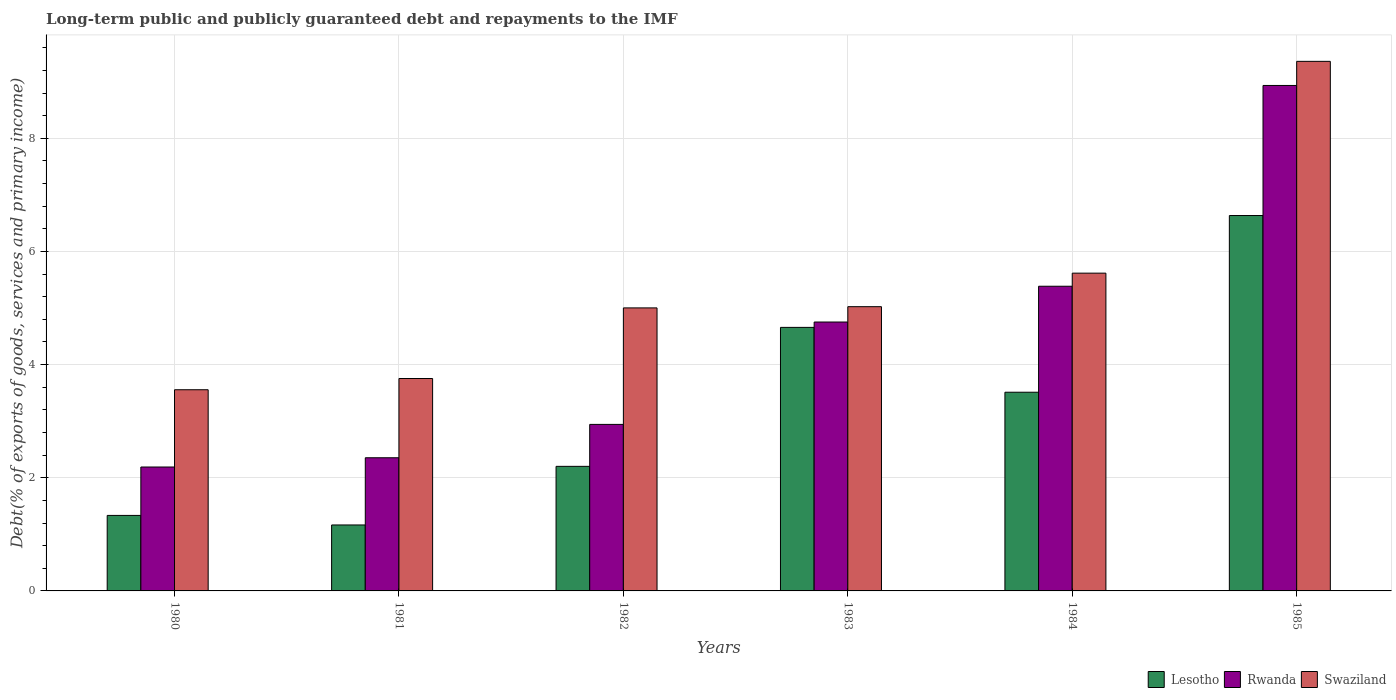Are the number of bars per tick equal to the number of legend labels?
Your answer should be compact. Yes. Are the number of bars on each tick of the X-axis equal?
Give a very brief answer. Yes. How many bars are there on the 3rd tick from the left?
Provide a short and direct response. 3. How many bars are there on the 5th tick from the right?
Your answer should be compact. 3. What is the label of the 6th group of bars from the left?
Provide a succinct answer. 1985. What is the debt and repayments in Swaziland in 1981?
Your answer should be compact. 3.75. Across all years, what is the maximum debt and repayments in Rwanda?
Your answer should be very brief. 8.93. Across all years, what is the minimum debt and repayments in Swaziland?
Your answer should be compact. 3.56. What is the total debt and repayments in Rwanda in the graph?
Provide a short and direct response. 26.56. What is the difference between the debt and repayments in Rwanda in 1980 and that in 1981?
Keep it short and to the point. -0.16. What is the difference between the debt and repayments in Rwanda in 1981 and the debt and repayments in Lesotho in 1980?
Offer a very short reply. 1.02. What is the average debt and repayments in Rwanda per year?
Your answer should be compact. 4.43. In the year 1981, what is the difference between the debt and repayments in Rwanda and debt and repayments in Lesotho?
Your answer should be very brief. 1.19. What is the ratio of the debt and repayments in Lesotho in 1983 to that in 1984?
Give a very brief answer. 1.33. Is the difference between the debt and repayments in Rwanda in 1980 and 1984 greater than the difference between the debt and repayments in Lesotho in 1980 and 1984?
Keep it short and to the point. No. What is the difference between the highest and the second highest debt and repayments in Rwanda?
Offer a very short reply. 3.55. What is the difference between the highest and the lowest debt and repayments in Lesotho?
Provide a short and direct response. 5.47. In how many years, is the debt and repayments in Rwanda greater than the average debt and repayments in Rwanda taken over all years?
Keep it short and to the point. 3. Is the sum of the debt and repayments in Rwanda in 1981 and 1983 greater than the maximum debt and repayments in Lesotho across all years?
Keep it short and to the point. Yes. What does the 1st bar from the left in 1980 represents?
Make the answer very short. Lesotho. What does the 3rd bar from the right in 1985 represents?
Offer a terse response. Lesotho. How many bars are there?
Your response must be concise. 18. How many years are there in the graph?
Give a very brief answer. 6. What is the difference between two consecutive major ticks on the Y-axis?
Ensure brevity in your answer.  2. Are the values on the major ticks of Y-axis written in scientific E-notation?
Make the answer very short. No. Does the graph contain grids?
Offer a terse response. Yes. Where does the legend appear in the graph?
Provide a short and direct response. Bottom right. How many legend labels are there?
Give a very brief answer. 3. What is the title of the graph?
Make the answer very short. Long-term public and publicly guaranteed debt and repayments to the IMF. What is the label or title of the X-axis?
Give a very brief answer. Years. What is the label or title of the Y-axis?
Your response must be concise. Debt(% of exports of goods, services and primary income). What is the Debt(% of exports of goods, services and primary income) in Lesotho in 1980?
Make the answer very short. 1.33. What is the Debt(% of exports of goods, services and primary income) of Rwanda in 1980?
Provide a short and direct response. 2.19. What is the Debt(% of exports of goods, services and primary income) in Swaziland in 1980?
Offer a terse response. 3.56. What is the Debt(% of exports of goods, services and primary income) in Lesotho in 1981?
Your answer should be compact. 1.17. What is the Debt(% of exports of goods, services and primary income) of Rwanda in 1981?
Make the answer very short. 2.35. What is the Debt(% of exports of goods, services and primary income) of Swaziland in 1981?
Provide a short and direct response. 3.75. What is the Debt(% of exports of goods, services and primary income) in Lesotho in 1982?
Your response must be concise. 2.2. What is the Debt(% of exports of goods, services and primary income) of Rwanda in 1982?
Provide a succinct answer. 2.94. What is the Debt(% of exports of goods, services and primary income) of Swaziland in 1982?
Provide a short and direct response. 5. What is the Debt(% of exports of goods, services and primary income) in Lesotho in 1983?
Your response must be concise. 4.66. What is the Debt(% of exports of goods, services and primary income) of Rwanda in 1983?
Offer a terse response. 4.75. What is the Debt(% of exports of goods, services and primary income) of Swaziland in 1983?
Provide a succinct answer. 5.02. What is the Debt(% of exports of goods, services and primary income) of Lesotho in 1984?
Provide a succinct answer. 3.51. What is the Debt(% of exports of goods, services and primary income) in Rwanda in 1984?
Provide a succinct answer. 5.38. What is the Debt(% of exports of goods, services and primary income) in Swaziland in 1984?
Your answer should be very brief. 5.62. What is the Debt(% of exports of goods, services and primary income) of Lesotho in 1985?
Your response must be concise. 6.63. What is the Debt(% of exports of goods, services and primary income) in Rwanda in 1985?
Ensure brevity in your answer.  8.93. What is the Debt(% of exports of goods, services and primary income) of Swaziland in 1985?
Offer a very short reply. 9.36. Across all years, what is the maximum Debt(% of exports of goods, services and primary income) in Lesotho?
Your answer should be compact. 6.63. Across all years, what is the maximum Debt(% of exports of goods, services and primary income) in Rwanda?
Provide a short and direct response. 8.93. Across all years, what is the maximum Debt(% of exports of goods, services and primary income) of Swaziland?
Give a very brief answer. 9.36. Across all years, what is the minimum Debt(% of exports of goods, services and primary income) of Lesotho?
Your answer should be very brief. 1.17. Across all years, what is the minimum Debt(% of exports of goods, services and primary income) of Rwanda?
Your answer should be very brief. 2.19. Across all years, what is the minimum Debt(% of exports of goods, services and primary income) of Swaziland?
Your answer should be very brief. 3.56. What is the total Debt(% of exports of goods, services and primary income) of Lesotho in the graph?
Your response must be concise. 19.51. What is the total Debt(% of exports of goods, services and primary income) in Rwanda in the graph?
Keep it short and to the point. 26.56. What is the total Debt(% of exports of goods, services and primary income) of Swaziland in the graph?
Keep it short and to the point. 32.31. What is the difference between the Debt(% of exports of goods, services and primary income) in Lesotho in 1980 and that in 1981?
Provide a succinct answer. 0.17. What is the difference between the Debt(% of exports of goods, services and primary income) in Rwanda in 1980 and that in 1981?
Provide a succinct answer. -0.16. What is the difference between the Debt(% of exports of goods, services and primary income) in Swaziland in 1980 and that in 1981?
Offer a very short reply. -0.2. What is the difference between the Debt(% of exports of goods, services and primary income) in Lesotho in 1980 and that in 1982?
Make the answer very short. -0.87. What is the difference between the Debt(% of exports of goods, services and primary income) of Rwanda in 1980 and that in 1982?
Provide a short and direct response. -0.75. What is the difference between the Debt(% of exports of goods, services and primary income) of Swaziland in 1980 and that in 1982?
Make the answer very short. -1.45. What is the difference between the Debt(% of exports of goods, services and primary income) in Lesotho in 1980 and that in 1983?
Provide a short and direct response. -3.32. What is the difference between the Debt(% of exports of goods, services and primary income) in Rwanda in 1980 and that in 1983?
Keep it short and to the point. -2.56. What is the difference between the Debt(% of exports of goods, services and primary income) in Swaziland in 1980 and that in 1983?
Make the answer very short. -1.47. What is the difference between the Debt(% of exports of goods, services and primary income) in Lesotho in 1980 and that in 1984?
Your response must be concise. -2.18. What is the difference between the Debt(% of exports of goods, services and primary income) of Rwanda in 1980 and that in 1984?
Offer a very short reply. -3.19. What is the difference between the Debt(% of exports of goods, services and primary income) in Swaziland in 1980 and that in 1984?
Keep it short and to the point. -2.06. What is the difference between the Debt(% of exports of goods, services and primary income) of Lesotho in 1980 and that in 1985?
Offer a very short reply. -5.3. What is the difference between the Debt(% of exports of goods, services and primary income) of Rwanda in 1980 and that in 1985?
Your answer should be very brief. -6.74. What is the difference between the Debt(% of exports of goods, services and primary income) of Swaziland in 1980 and that in 1985?
Provide a succinct answer. -5.8. What is the difference between the Debt(% of exports of goods, services and primary income) of Lesotho in 1981 and that in 1982?
Give a very brief answer. -1.04. What is the difference between the Debt(% of exports of goods, services and primary income) in Rwanda in 1981 and that in 1982?
Give a very brief answer. -0.59. What is the difference between the Debt(% of exports of goods, services and primary income) of Swaziland in 1981 and that in 1982?
Offer a terse response. -1.25. What is the difference between the Debt(% of exports of goods, services and primary income) in Lesotho in 1981 and that in 1983?
Your response must be concise. -3.49. What is the difference between the Debt(% of exports of goods, services and primary income) in Rwanda in 1981 and that in 1983?
Offer a very short reply. -2.4. What is the difference between the Debt(% of exports of goods, services and primary income) of Swaziland in 1981 and that in 1983?
Your answer should be very brief. -1.27. What is the difference between the Debt(% of exports of goods, services and primary income) in Lesotho in 1981 and that in 1984?
Offer a very short reply. -2.35. What is the difference between the Debt(% of exports of goods, services and primary income) in Rwanda in 1981 and that in 1984?
Provide a short and direct response. -3.03. What is the difference between the Debt(% of exports of goods, services and primary income) in Swaziland in 1981 and that in 1984?
Your answer should be very brief. -1.86. What is the difference between the Debt(% of exports of goods, services and primary income) in Lesotho in 1981 and that in 1985?
Make the answer very short. -5.47. What is the difference between the Debt(% of exports of goods, services and primary income) of Rwanda in 1981 and that in 1985?
Give a very brief answer. -6.58. What is the difference between the Debt(% of exports of goods, services and primary income) of Swaziland in 1981 and that in 1985?
Keep it short and to the point. -5.61. What is the difference between the Debt(% of exports of goods, services and primary income) in Lesotho in 1982 and that in 1983?
Your answer should be compact. -2.46. What is the difference between the Debt(% of exports of goods, services and primary income) of Rwanda in 1982 and that in 1983?
Provide a succinct answer. -1.81. What is the difference between the Debt(% of exports of goods, services and primary income) of Swaziland in 1982 and that in 1983?
Provide a short and direct response. -0.02. What is the difference between the Debt(% of exports of goods, services and primary income) of Lesotho in 1982 and that in 1984?
Your answer should be very brief. -1.31. What is the difference between the Debt(% of exports of goods, services and primary income) in Rwanda in 1982 and that in 1984?
Provide a short and direct response. -2.44. What is the difference between the Debt(% of exports of goods, services and primary income) in Swaziland in 1982 and that in 1984?
Your answer should be very brief. -0.61. What is the difference between the Debt(% of exports of goods, services and primary income) in Lesotho in 1982 and that in 1985?
Ensure brevity in your answer.  -4.43. What is the difference between the Debt(% of exports of goods, services and primary income) in Rwanda in 1982 and that in 1985?
Give a very brief answer. -5.99. What is the difference between the Debt(% of exports of goods, services and primary income) in Swaziland in 1982 and that in 1985?
Offer a very short reply. -4.36. What is the difference between the Debt(% of exports of goods, services and primary income) in Lesotho in 1983 and that in 1984?
Keep it short and to the point. 1.15. What is the difference between the Debt(% of exports of goods, services and primary income) in Rwanda in 1983 and that in 1984?
Make the answer very short. -0.63. What is the difference between the Debt(% of exports of goods, services and primary income) of Swaziland in 1983 and that in 1984?
Your response must be concise. -0.59. What is the difference between the Debt(% of exports of goods, services and primary income) in Lesotho in 1983 and that in 1985?
Provide a short and direct response. -1.98. What is the difference between the Debt(% of exports of goods, services and primary income) of Rwanda in 1983 and that in 1985?
Offer a very short reply. -4.18. What is the difference between the Debt(% of exports of goods, services and primary income) of Swaziland in 1983 and that in 1985?
Offer a very short reply. -4.34. What is the difference between the Debt(% of exports of goods, services and primary income) of Lesotho in 1984 and that in 1985?
Give a very brief answer. -3.12. What is the difference between the Debt(% of exports of goods, services and primary income) in Rwanda in 1984 and that in 1985?
Keep it short and to the point. -3.55. What is the difference between the Debt(% of exports of goods, services and primary income) in Swaziland in 1984 and that in 1985?
Offer a terse response. -3.74. What is the difference between the Debt(% of exports of goods, services and primary income) in Lesotho in 1980 and the Debt(% of exports of goods, services and primary income) in Rwanda in 1981?
Provide a succinct answer. -1.02. What is the difference between the Debt(% of exports of goods, services and primary income) of Lesotho in 1980 and the Debt(% of exports of goods, services and primary income) of Swaziland in 1981?
Provide a short and direct response. -2.42. What is the difference between the Debt(% of exports of goods, services and primary income) of Rwanda in 1980 and the Debt(% of exports of goods, services and primary income) of Swaziland in 1981?
Ensure brevity in your answer.  -1.56. What is the difference between the Debt(% of exports of goods, services and primary income) of Lesotho in 1980 and the Debt(% of exports of goods, services and primary income) of Rwanda in 1982?
Give a very brief answer. -1.61. What is the difference between the Debt(% of exports of goods, services and primary income) of Lesotho in 1980 and the Debt(% of exports of goods, services and primary income) of Swaziland in 1982?
Offer a very short reply. -3.67. What is the difference between the Debt(% of exports of goods, services and primary income) of Rwanda in 1980 and the Debt(% of exports of goods, services and primary income) of Swaziland in 1982?
Offer a very short reply. -2.81. What is the difference between the Debt(% of exports of goods, services and primary income) in Lesotho in 1980 and the Debt(% of exports of goods, services and primary income) in Rwanda in 1983?
Make the answer very short. -3.42. What is the difference between the Debt(% of exports of goods, services and primary income) in Lesotho in 1980 and the Debt(% of exports of goods, services and primary income) in Swaziland in 1983?
Your response must be concise. -3.69. What is the difference between the Debt(% of exports of goods, services and primary income) of Rwanda in 1980 and the Debt(% of exports of goods, services and primary income) of Swaziland in 1983?
Keep it short and to the point. -2.83. What is the difference between the Debt(% of exports of goods, services and primary income) of Lesotho in 1980 and the Debt(% of exports of goods, services and primary income) of Rwanda in 1984?
Provide a short and direct response. -4.05. What is the difference between the Debt(% of exports of goods, services and primary income) of Lesotho in 1980 and the Debt(% of exports of goods, services and primary income) of Swaziland in 1984?
Your answer should be compact. -4.28. What is the difference between the Debt(% of exports of goods, services and primary income) in Rwanda in 1980 and the Debt(% of exports of goods, services and primary income) in Swaziland in 1984?
Offer a very short reply. -3.43. What is the difference between the Debt(% of exports of goods, services and primary income) of Lesotho in 1980 and the Debt(% of exports of goods, services and primary income) of Rwanda in 1985?
Provide a succinct answer. -7.6. What is the difference between the Debt(% of exports of goods, services and primary income) of Lesotho in 1980 and the Debt(% of exports of goods, services and primary income) of Swaziland in 1985?
Ensure brevity in your answer.  -8.02. What is the difference between the Debt(% of exports of goods, services and primary income) of Rwanda in 1980 and the Debt(% of exports of goods, services and primary income) of Swaziland in 1985?
Keep it short and to the point. -7.17. What is the difference between the Debt(% of exports of goods, services and primary income) in Lesotho in 1981 and the Debt(% of exports of goods, services and primary income) in Rwanda in 1982?
Your response must be concise. -1.78. What is the difference between the Debt(% of exports of goods, services and primary income) of Lesotho in 1981 and the Debt(% of exports of goods, services and primary income) of Swaziland in 1982?
Provide a succinct answer. -3.84. What is the difference between the Debt(% of exports of goods, services and primary income) of Rwanda in 1981 and the Debt(% of exports of goods, services and primary income) of Swaziland in 1982?
Your answer should be compact. -2.65. What is the difference between the Debt(% of exports of goods, services and primary income) in Lesotho in 1981 and the Debt(% of exports of goods, services and primary income) in Rwanda in 1983?
Offer a very short reply. -3.59. What is the difference between the Debt(% of exports of goods, services and primary income) of Lesotho in 1981 and the Debt(% of exports of goods, services and primary income) of Swaziland in 1983?
Keep it short and to the point. -3.86. What is the difference between the Debt(% of exports of goods, services and primary income) of Rwanda in 1981 and the Debt(% of exports of goods, services and primary income) of Swaziland in 1983?
Keep it short and to the point. -2.67. What is the difference between the Debt(% of exports of goods, services and primary income) of Lesotho in 1981 and the Debt(% of exports of goods, services and primary income) of Rwanda in 1984?
Your answer should be very brief. -4.22. What is the difference between the Debt(% of exports of goods, services and primary income) of Lesotho in 1981 and the Debt(% of exports of goods, services and primary income) of Swaziland in 1984?
Your response must be concise. -4.45. What is the difference between the Debt(% of exports of goods, services and primary income) of Rwanda in 1981 and the Debt(% of exports of goods, services and primary income) of Swaziland in 1984?
Offer a very short reply. -3.26. What is the difference between the Debt(% of exports of goods, services and primary income) in Lesotho in 1981 and the Debt(% of exports of goods, services and primary income) in Rwanda in 1985?
Provide a succinct answer. -7.77. What is the difference between the Debt(% of exports of goods, services and primary income) of Lesotho in 1981 and the Debt(% of exports of goods, services and primary income) of Swaziland in 1985?
Provide a succinct answer. -8.19. What is the difference between the Debt(% of exports of goods, services and primary income) of Rwanda in 1981 and the Debt(% of exports of goods, services and primary income) of Swaziland in 1985?
Your answer should be very brief. -7.01. What is the difference between the Debt(% of exports of goods, services and primary income) in Lesotho in 1982 and the Debt(% of exports of goods, services and primary income) in Rwanda in 1983?
Your response must be concise. -2.55. What is the difference between the Debt(% of exports of goods, services and primary income) of Lesotho in 1982 and the Debt(% of exports of goods, services and primary income) of Swaziland in 1983?
Provide a short and direct response. -2.82. What is the difference between the Debt(% of exports of goods, services and primary income) of Rwanda in 1982 and the Debt(% of exports of goods, services and primary income) of Swaziland in 1983?
Keep it short and to the point. -2.08. What is the difference between the Debt(% of exports of goods, services and primary income) of Lesotho in 1982 and the Debt(% of exports of goods, services and primary income) of Rwanda in 1984?
Your response must be concise. -3.18. What is the difference between the Debt(% of exports of goods, services and primary income) in Lesotho in 1982 and the Debt(% of exports of goods, services and primary income) in Swaziland in 1984?
Make the answer very short. -3.41. What is the difference between the Debt(% of exports of goods, services and primary income) in Rwanda in 1982 and the Debt(% of exports of goods, services and primary income) in Swaziland in 1984?
Ensure brevity in your answer.  -2.67. What is the difference between the Debt(% of exports of goods, services and primary income) of Lesotho in 1982 and the Debt(% of exports of goods, services and primary income) of Rwanda in 1985?
Your response must be concise. -6.73. What is the difference between the Debt(% of exports of goods, services and primary income) of Lesotho in 1982 and the Debt(% of exports of goods, services and primary income) of Swaziland in 1985?
Ensure brevity in your answer.  -7.16. What is the difference between the Debt(% of exports of goods, services and primary income) of Rwanda in 1982 and the Debt(% of exports of goods, services and primary income) of Swaziland in 1985?
Offer a terse response. -6.42. What is the difference between the Debt(% of exports of goods, services and primary income) of Lesotho in 1983 and the Debt(% of exports of goods, services and primary income) of Rwanda in 1984?
Offer a terse response. -0.73. What is the difference between the Debt(% of exports of goods, services and primary income) in Lesotho in 1983 and the Debt(% of exports of goods, services and primary income) in Swaziland in 1984?
Offer a terse response. -0.96. What is the difference between the Debt(% of exports of goods, services and primary income) of Rwanda in 1983 and the Debt(% of exports of goods, services and primary income) of Swaziland in 1984?
Give a very brief answer. -0.86. What is the difference between the Debt(% of exports of goods, services and primary income) in Lesotho in 1983 and the Debt(% of exports of goods, services and primary income) in Rwanda in 1985?
Your answer should be very brief. -4.28. What is the difference between the Debt(% of exports of goods, services and primary income) of Lesotho in 1983 and the Debt(% of exports of goods, services and primary income) of Swaziland in 1985?
Your response must be concise. -4.7. What is the difference between the Debt(% of exports of goods, services and primary income) of Rwanda in 1983 and the Debt(% of exports of goods, services and primary income) of Swaziland in 1985?
Keep it short and to the point. -4.61. What is the difference between the Debt(% of exports of goods, services and primary income) in Lesotho in 1984 and the Debt(% of exports of goods, services and primary income) in Rwanda in 1985?
Offer a terse response. -5.42. What is the difference between the Debt(% of exports of goods, services and primary income) in Lesotho in 1984 and the Debt(% of exports of goods, services and primary income) in Swaziland in 1985?
Your response must be concise. -5.85. What is the difference between the Debt(% of exports of goods, services and primary income) in Rwanda in 1984 and the Debt(% of exports of goods, services and primary income) in Swaziland in 1985?
Keep it short and to the point. -3.97. What is the average Debt(% of exports of goods, services and primary income) in Lesotho per year?
Ensure brevity in your answer.  3.25. What is the average Debt(% of exports of goods, services and primary income) in Rwanda per year?
Provide a short and direct response. 4.43. What is the average Debt(% of exports of goods, services and primary income) of Swaziland per year?
Provide a short and direct response. 5.39. In the year 1980, what is the difference between the Debt(% of exports of goods, services and primary income) of Lesotho and Debt(% of exports of goods, services and primary income) of Rwanda?
Your answer should be compact. -0.86. In the year 1980, what is the difference between the Debt(% of exports of goods, services and primary income) in Lesotho and Debt(% of exports of goods, services and primary income) in Swaziland?
Your response must be concise. -2.22. In the year 1980, what is the difference between the Debt(% of exports of goods, services and primary income) of Rwanda and Debt(% of exports of goods, services and primary income) of Swaziland?
Offer a very short reply. -1.37. In the year 1981, what is the difference between the Debt(% of exports of goods, services and primary income) of Lesotho and Debt(% of exports of goods, services and primary income) of Rwanda?
Provide a short and direct response. -1.19. In the year 1981, what is the difference between the Debt(% of exports of goods, services and primary income) in Lesotho and Debt(% of exports of goods, services and primary income) in Swaziland?
Your response must be concise. -2.59. In the year 1981, what is the difference between the Debt(% of exports of goods, services and primary income) in Rwanda and Debt(% of exports of goods, services and primary income) in Swaziland?
Your response must be concise. -1.4. In the year 1982, what is the difference between the Debt(% of exports of goods, services and primary income) of Lesotho and Debt(% of exports of goods, services and primary income) of Rwanda?
Keep it short and to the point. -0.74. In the year 1982, what is the difference between the Debt(% of exports of goods, services and primary income) of Lesotho and Debt(% of exports of goods, services and primary income) of Swaziland?
Your answer should be compact. -2.8. In the year 1982, what is the difference between the Debt(% of exports of goods, services and primary income) in Rwanda and Debt(% of exports of goods, services and primary income) in Swaziland?
Offer a terse response. -2.06. In the year 1983, what is the difference between the Debt(% of exports of goods, services and primary income) in Lesotho and Debt(% of exports of goods, services and primary income) in Rwanda?
Your response must be concise. -0.09. In the year 1983, what is the difference between the Debt(% of exports of goods, services and primary income) of Lesotho and Debt(% of exports of goods, services and primary income) of Swaziland?
Ensure brevity in your answer.  -0.37. In the year 1983, what is the difference between the Debt(% of exports of goods, services and primary income) in Rwanda and Debt(% of exports of goods, services and primary income) in Swaziland?
Your answer should be compact. -0.27. In the year 1984, what is the difference between the Debt(% of exports of goods, services and primary income) in Lesotho and Debt(% of exports of goods, services and primary income) in Rwanda?
Keep it short and to the point. -1.87. In the year 1984, what is the difference between the Debt(% of exports of goods, services and primary income) of Lesotho and Debt(% of exports of goods, services and primary income) of Swaziland?
Your answer should be compact. -2.1. In the year 1984, what is the difference between the Debt(% of exports of goods, services and primary income) in Rwanda and Debt(% of exports of goods, services and primary income) in Swaziland?
Offer a very short reply. -0.23. In the year 1985, what is the difference between the Debt(% of exports of goods, services and primary income) of Lesotho and Debt(% of exports of goods, services and primary income) of Rwanda?
Your answer should be very brief. -2.3. In the year 1985, what is the difference between the Debt(% of exports of goods, services and primary income) in Lesotho and Debt(% of exports of goods, services and primary income) in Swaziland?
Give a very brief answer. -2.72. In the year 1985, what is the difference between the Debt(% of exports of goods, services and primary income) of Rwanda and Debt(% of exports of goods, services and primary income) of Swaziland?
Your response must be concise. -0.43. What is the ratio of the Debt(% of exports of goods, services and primary income) in Lesotho in 1980 to that in 1981?
Your answer should be compact. 1.14. What is the ratio of the Debt(% of exports of goods, services and primary income) in Rwanda in 1980 to that in 1981?
Keep it short and to the point. 0.93. What is the ratio of the Debt(% of exports of goods, services and primary income) in Swaziland in 1980 to that in 1981?
Offer a very short reply. 0.95. What is the ratio of the Debt(% of exports of goods, services and primary income) of Lesotho in 1980 to that in 1982?
Offer a very short reply. 0.61. What is the ratio of the Debt(% of exports of goods, services and primary income) in Rwanda in 1980 to that in 1982?
Provide a succinct answer. 0.74. What is the ratio of the Debt(% of exports of goods, services and primary income) of Swaziland in 1980 to that in 1982?
Provide a short and direct response. 0.71. What is the ratio of the Debt(% of exports of goods, services and primary income) of Lesotho in 1980 to that in 1983?
Your answer should be compact. 0.29. What is the ratio of the Debt(% of exports of goods, services and primary income) in Rwanda in 1980 to that in 1983?
Give a very brief answer. 0.46. What is the ratio of the Debt(% of exports of goods, services and primary income) in Swaziland in 1980 to that in 1983?
Your answer should be very brief. 0.71. What is the ratio of the Debt(% of exports of goods, services and primary income) of Lesotho in 1980 to that in 1984?
Your answer should be compact. 0.38. What is the ratio of the Debt(% of exports of goods, services and primary income) of Rwanda in 1980 to that in 1984?
Offer a very short reply. 0.41. What is the ratio of the Debt(% of exports of goods, services and primary income) of Swaziland in 1980 to that in 1984?
Your answer should be compact. 0.63. What is the ratio of the Debt(% of exports of goods, services and primary income) of Lesotho in 1980 to that in 1985?
Provide a short and direct response. 0.2. What is the ratio of the Debt(% of exports of goods, services and primary income) of Rwanda in 1980 to that in 1985?
Give a very brief answer. 0.25. What is the ratio of the Debt(% of exports of goods, services and primary income) in Swaziland in 1980 to that in 1985?
Offer a terse response. 0.38. What is the ratio of the Debt(% of exports of goods, services and primary income) in Lesotho in 1981 to that in 1982?
Your answer should be very brief. 0.53. What is the ratio of the Debt(% of exports of goods, services and primary income) in Rwanda in 1981 to that in 1982?
Provide a succinct answer. 0.8. What is the ratio of the Debt(% of exports of goods, services and primary income) in Swaziland in 1981 to that in 1982?
Ensure brevity in your answer.  0.75. What is the ratio of the Debt(% of exports of goods, services and primary income) in Lesotho in 1981 to that in 1983?
Ensure brevity in your answer.  0.25. What is the ratio of the Debt(% of exports of goods, services and primary income) in Rwanda in 1981 to that in 1983?
Offer a terse response. 0.5. What is the ratio of the Debt(% of exports of goods, services and primary income) of Swaziland in 1981 to that in 1983?
Your response must be concise. 0.75. What is the ratio of the Debt(% of exports of goods, services and primary income) in Lesotho in 1981 to that in 1984?
Your answer should be very brief. 0.33. What is the ratio of the Debt(% of exports of goods, services and primary income) in Rwanda in 1981 to that in 1984?
Offer a terse response. 0.44. What is the ratio of the Debt(% of exports of goods, services and primary income) of Swaziland in 1981 to that in 1984?
Provide a short and direct response. 0.67. What is the ratio of the Debt(% of exports of goods, services and primary income) in Lesotho in 1981 to that in 1985?
Offer a terse response. 0.18. What is the ratio of the Debt(% of exports of goods, services and primary income) of Rwanda in 1981 to that in 1985?
Make the answer very short. 0.26. What is the ratio of the Debt(% of exports of goods, services and primary income) in Swaziland in 1981 to that in 1985?
Make the answer very short. 0.4. What is the ratio of the Debt(% of exports of goods, services and primary income) in Lesotho in 1982 to that in 1983?
Your answer should be very brief. 0.47. What is the ratio of the Debt(% of exports of goods, services and primary income) in Rwanda in 1982 to that in 1983?
Keep it short and to the point. 0.62. What is the ratio of the Debt(% of exports of goods, services and primary income) of Swaziland in 1982 to that in 1983?
Offer a very short reply. 1. What is the ratio of the Debt(% of exports of goods, services and primary income) of Lesotho in 1982 to that in 1984?
Keep it short and to the point. 0.63. What is the ratio of the Debt(% of exports of goods, services and primary income) in Rwanda in 1982 to that in 1984?
Provide a short and direct response. 0.55. What is the ratio of the Debt(% of exports of goods, services and primary income) of Swaziland in 1982 to that in 1984?
Offer a terse response. 0.89. What is the ratio of the Debt(% of exports of goods, services and primary income) in Lesotho in 1982 to that in 1985?
Provide a short and direct response. 0.33. What is the ratio of the Debt(% of exports of goods, services and primary income) in Rwanda in 1982 to that in 1985?
Your answer should be compact. 0.33. What is the ratio of the Debt(% of exports of goods, services and primary income) in Swaziland in 1982 to that in 1985?
Give a very brief answer. 0.53. What is the ratio of the Debt(% of exports of goods, services and primary income) of Lesotho in 1983 to that in 1984?
Your response must be concise. 1.33. What is the ratio of the Debt(% of exports of goods, services and primary income) of Rwanda in 1983 to that in 1984?
Provide a succinct answer. 0.88. What is the ratio of the Debt(% of exports of goods, services and primary income) of Swaziland in 1983 to that in 1984?
Your response must be concise. 0.89. What is the ratio of the Debt(% of exports of goods, services and primary income) in Lesotho in 1983 to that in 1985?
Provide a short and direct response. 0.7. What is the ratio of the Debt(% of exports of goods, services and primary income) of Rwanda in 1983 to that in 1985?
Your answer should be compact. 0.53. What is the ratio of the Debt(% of exports of goods, services and primary income) in Swaziland in 1983 to that in 1985?
Offer a very short reply. 0.54. What is the ratio of the Debt(% of exports of goods, services and primary income) in Lesotho in 1984 to that in 1985?
Provide a succinct answer. 0.53. What is the ratio of the Debt(% of exports of goods, services and primary income) of Rwanda in 1984 to that in 1985?
Your response must be concise. 0.6. What is the ratio of the Debt(% of exports of goods, services and primary income) of Swaziland in 1984 to that in 1985?
Provide a short and direct response. 0.6. What is the difference between the highest and the second highest Debt(% of exports of goods, services and primary income) of Lesotho?
Make the answer very short. 1.98. What is the difference between the highest and the second highest Debt(% of exports of goods, services and primary income) of Rwanda?
Your answer should be very brief. 3.55. What is the difference between the highest and the second highest Debt(% of exports of goods, services and primary income) of Swaziland?
Keep it short and to the point. 3.74. What is the difference between the highest and the lowest Debt(% of exports of goods, services and primary income) of Lesotho?
Provide a short and direct response. 5.47. What is the difference between the highest and the lowest Debt(% of exports of goods, services and primary income) of Rwanda?
Make the answer very short. 6.74. What is the difference between the highest and the lowest Debt(% of exports of goods, services and primary income) of Swaziland?
Make the answer very short. 5.8. 